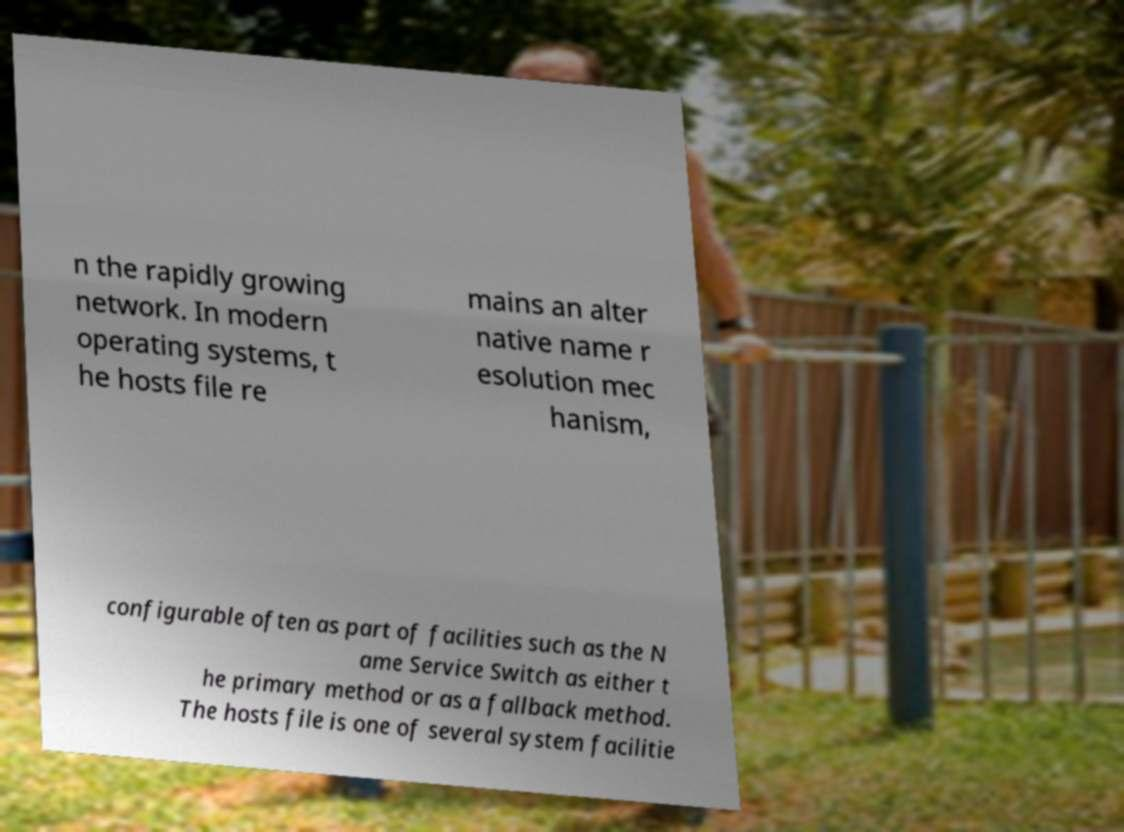Can you accurately transcribe the text from the provided image for me? n the rapidly growing network. In modern operating systems, t he hosts file re mains an alter native name r esolution mec hanism, configurable often as part of facilities such as the N ame Service Switch as either t he primary method or as a fallback method. The hosts file is one of several system facilitie 